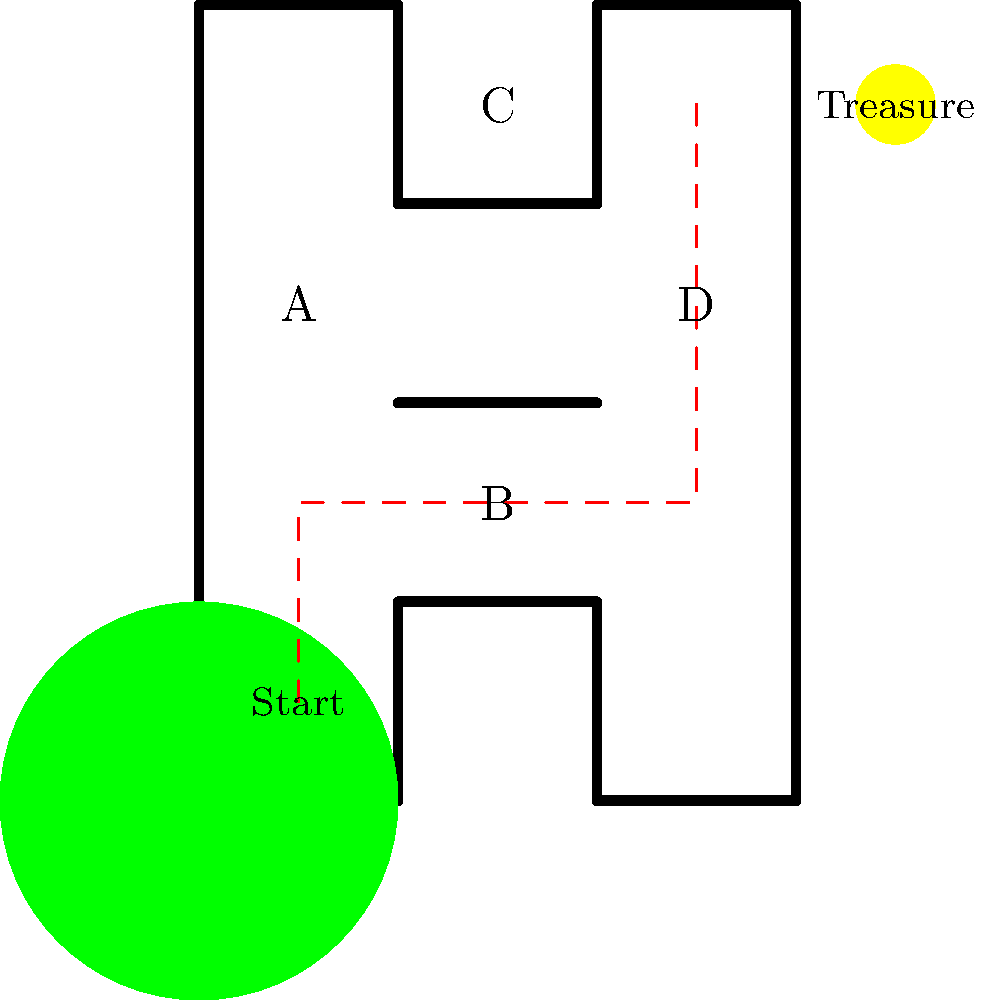Help Timmy find his way to the treasure chest! Which path should he take? Choose the correct sequence of letters that shows Timmy's path from start to finish. Let's follow Timmy's path step-by-step:

1. Timmy starts at the bottom-left corner of the maze.
2. He moves upward until he reaches point A.
3. From point A, he can't go left or right because of walls, so he continues moving up.
4. When he reaches the top, he turns right and moves until he reaches point B.
5. From point B, he can't go up because of a wall, so he continues moving right.
6. He passes point D and keeps moving right until he reaches the treasure chest.

The correct sequence of letters that Timmy passes through is A and B. He doesn't go through C or D.
Answer: AB 